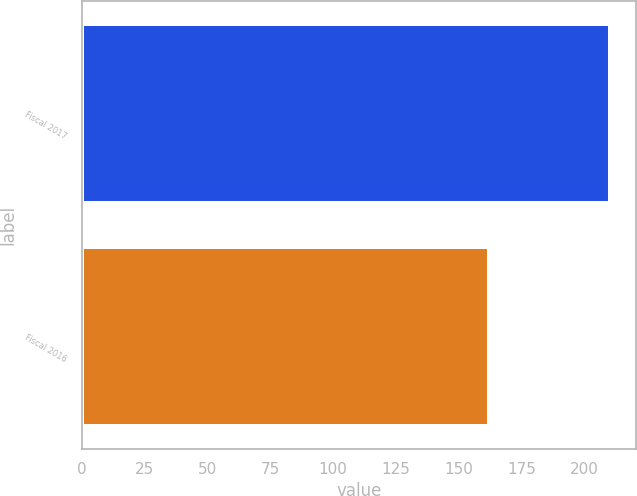Convert chart. <chart><loc_0><loc_0><loc_500><loc_500><bar_chart><fcel>Fiscal 2017<fcel>Fiscal 2016<nl><fcel>210.1<fcel>161.8<nl></chart> 